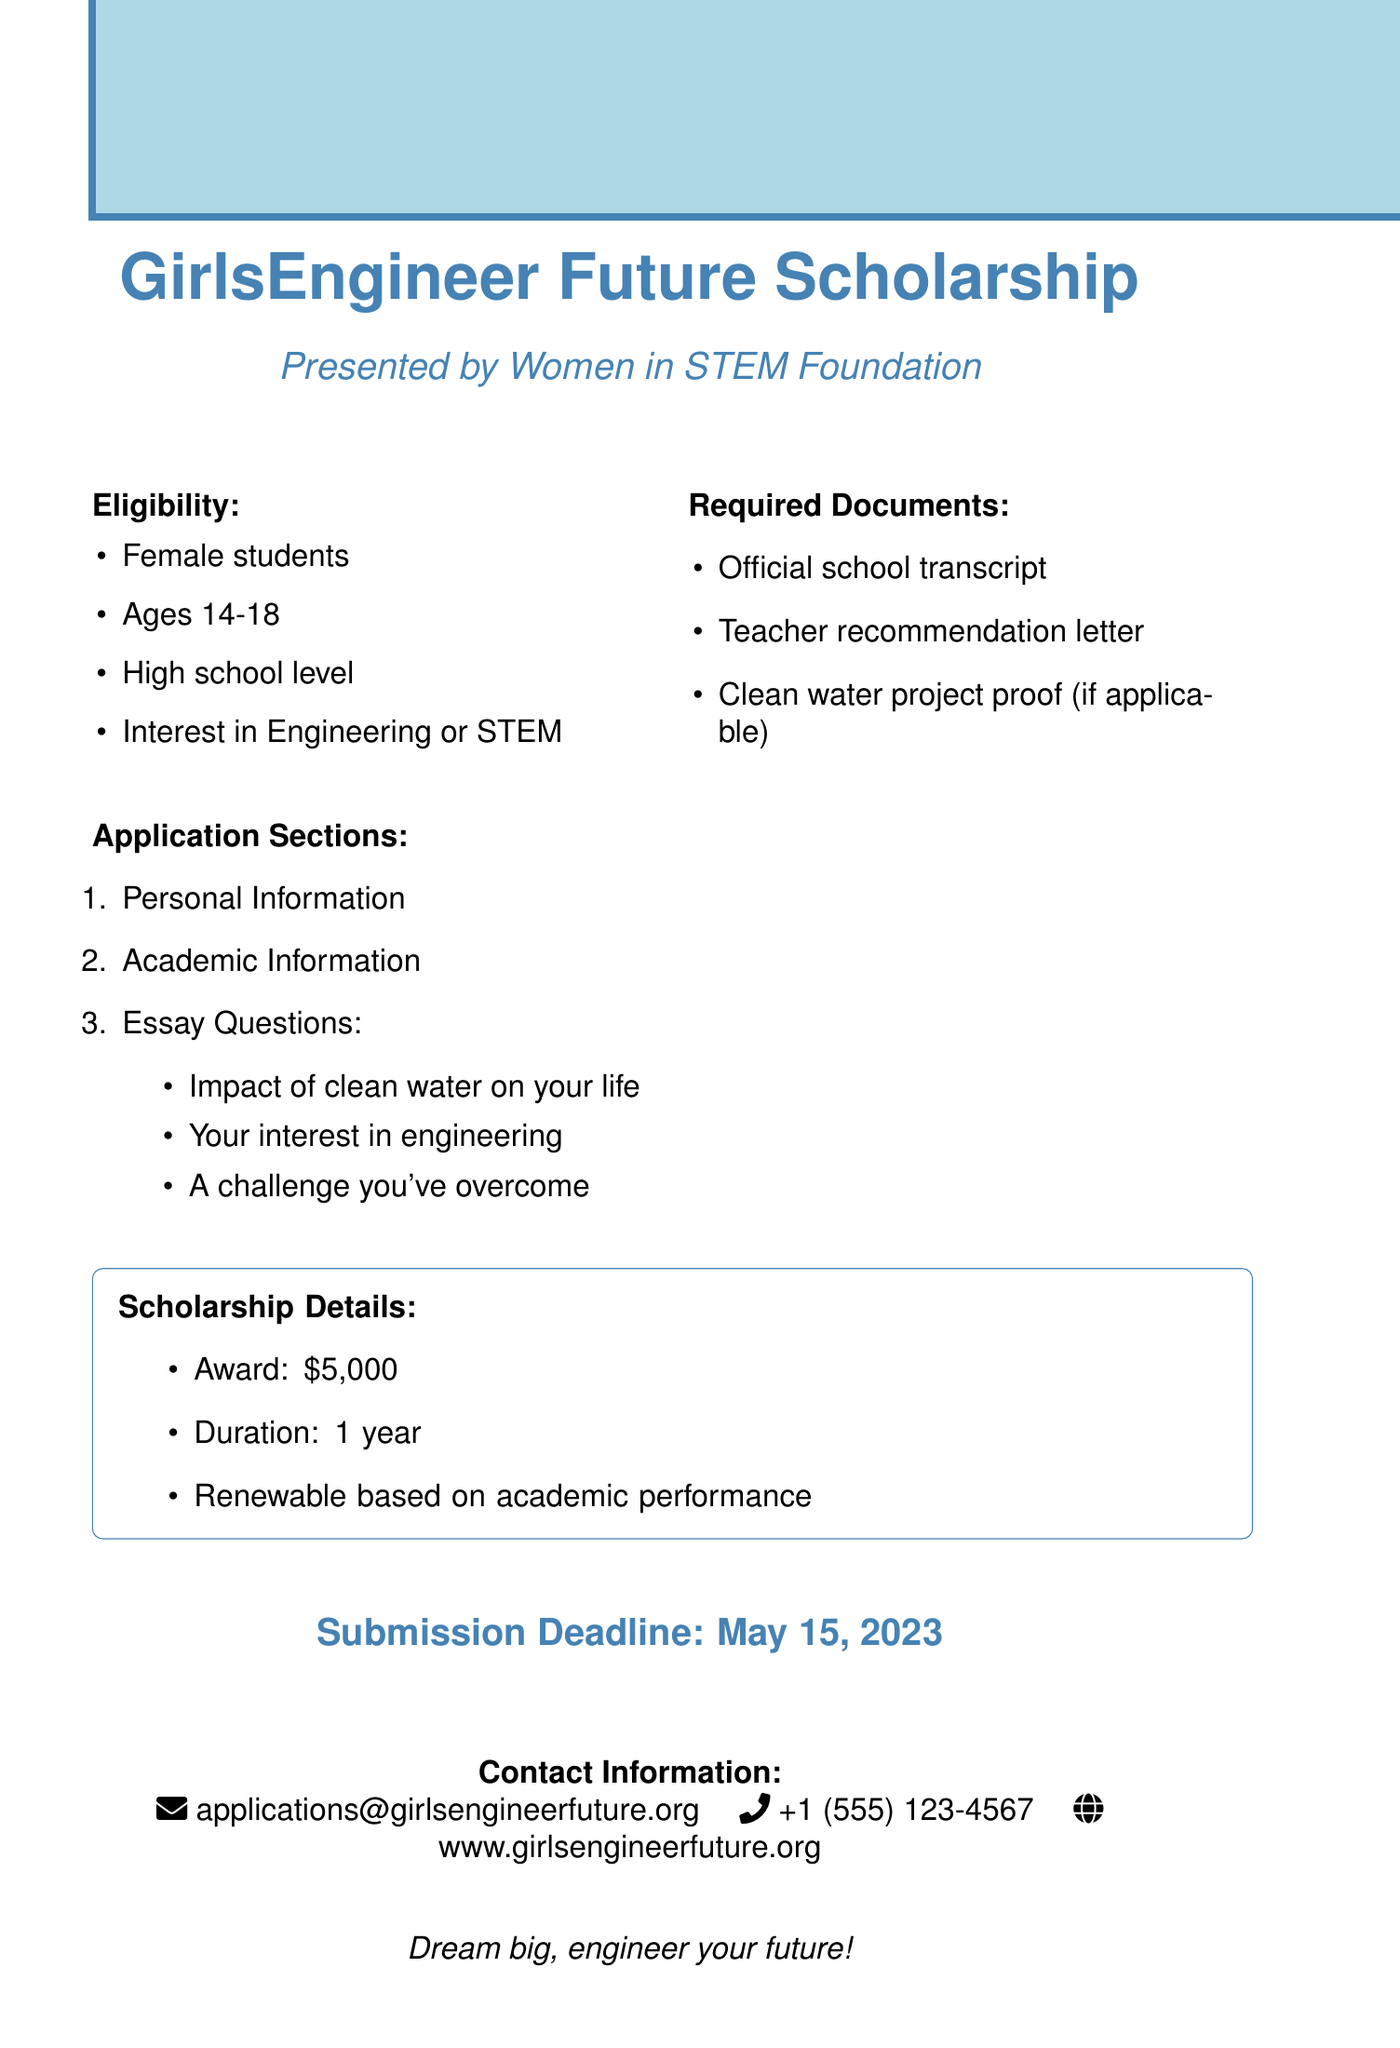What is the name of the scholarship? The name of the scholarship is specifically mentioned in the document.
Answer: GirlsEngineer Future Scholarship Who presents the scholarship? The document states the organization presenting the scholarship.
Answer: Women in STEM Foundation What is the age range for applicants? The document specifies the eligible age range for applicants.
Answer: 14-18 What is the award amount for the scholarship? The document details the amount awarded to successful applicants.
Answer: $5,000 When is the submission deadline? The document indicates the final date for submitting applications.
Answer: May 15, 2023 What must be included with the application? The document lists the required documents for application submission.
Answer: Official school transcript Why is participation in a clean water project relevant? The document states it as a condition if applicable, showing its importance in context.
Answer: Proof of participation in a clean water project How long is the scholarship duration? The document mentions the duration for which the scholarship will be awarded.
Answer: 1 year What is a topic of one essay question? The document includes specific prompts for essay questions applicants must answer.
Answer: Impact of clean water on your life Is the scholarship renewable? The document explicitly states the renewable nature based on a specified condition.
Answer: Yes, based on academic performance 